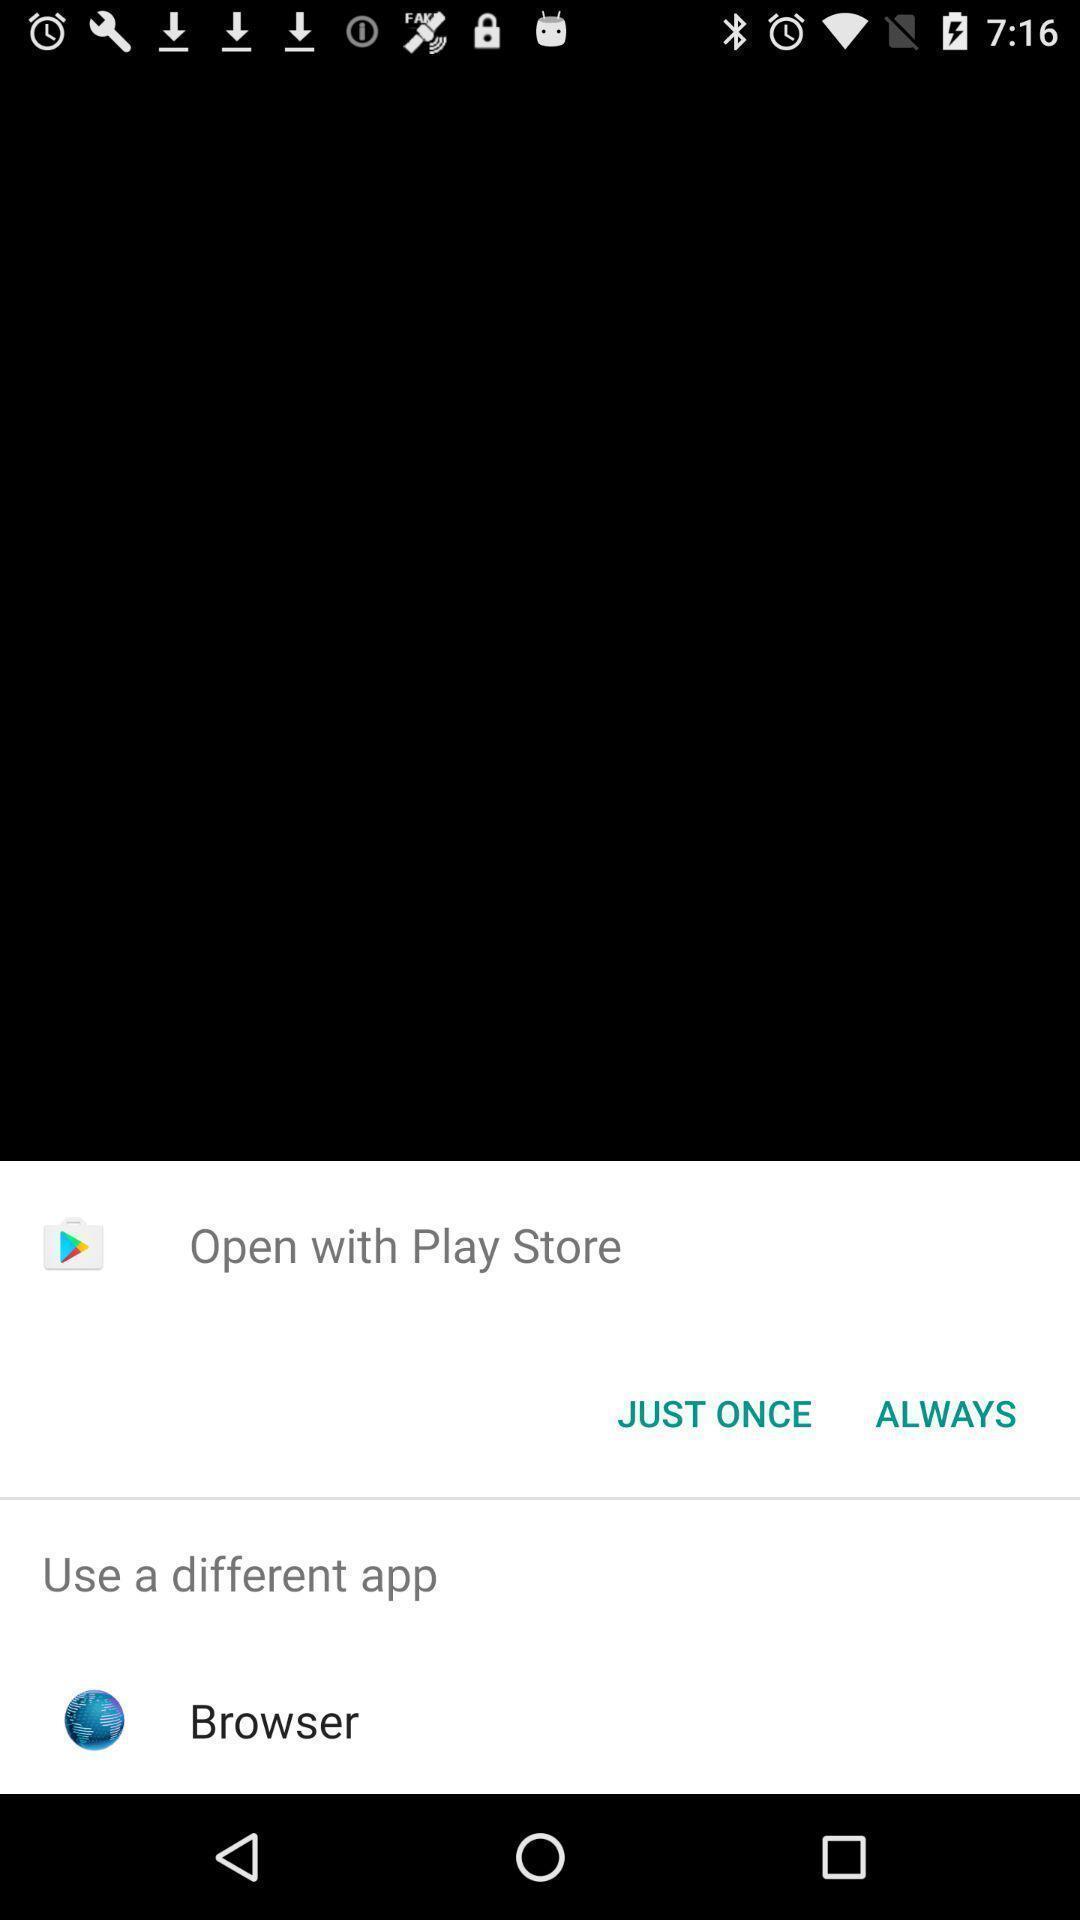Tell me what you see in this picture. Pop-up of play store app to open shopping app. 